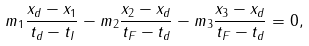Convert formula to latex. <formula><loc_0><loc_0><loc_500><loc_500>m _ { 1 } \frac { { x } _ { d } - { x } _ { 1 } } { t _ { d } - t _ { I } } - m _ { 2 } \frac { { x } _ { 2 } - { x } _ { d } } { t _ { F } - t _ { d } } - m _ { 3 } \frac { { x } _ { 3 } - { x } _ { d } } { t _ { F } - t _ { d } } = 0 ,</formula> 